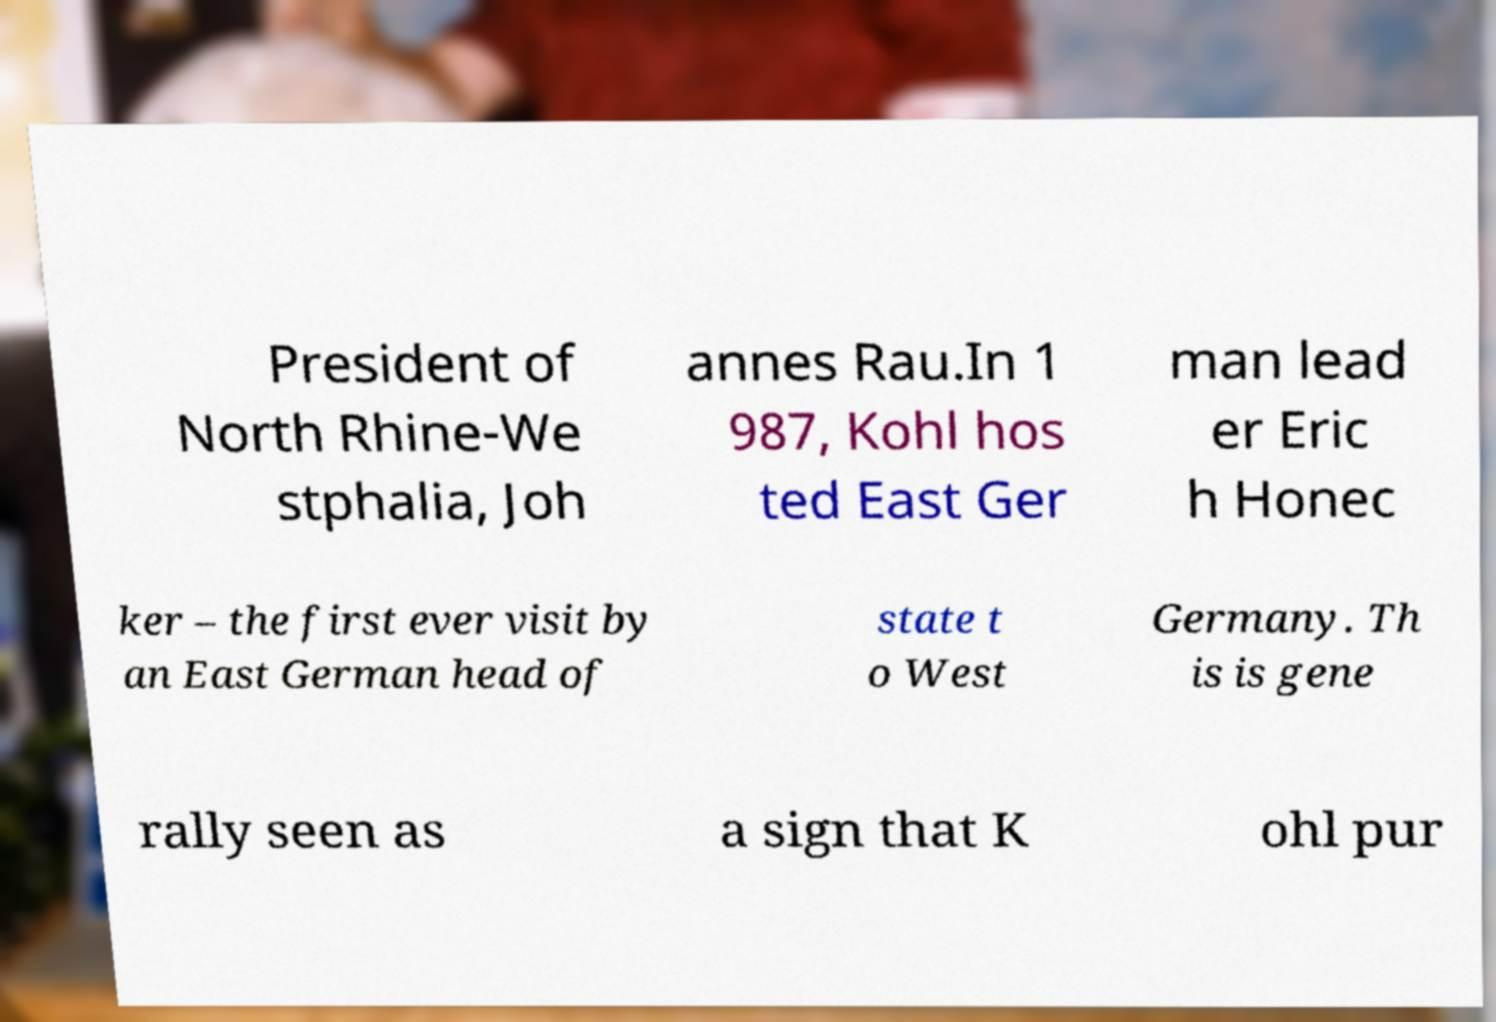For documentation purposes, I need the text within this image transcribed. Could you provide that? President of North Rhine-We stphalia, Joh annes Rau.In 1 987, Kohl hos ted East Ger man lead er Eric h Honec ker – the first ever visit by an East German head of state t o West Germany. Th is is gene rally seen as a sign that K ohl pur 